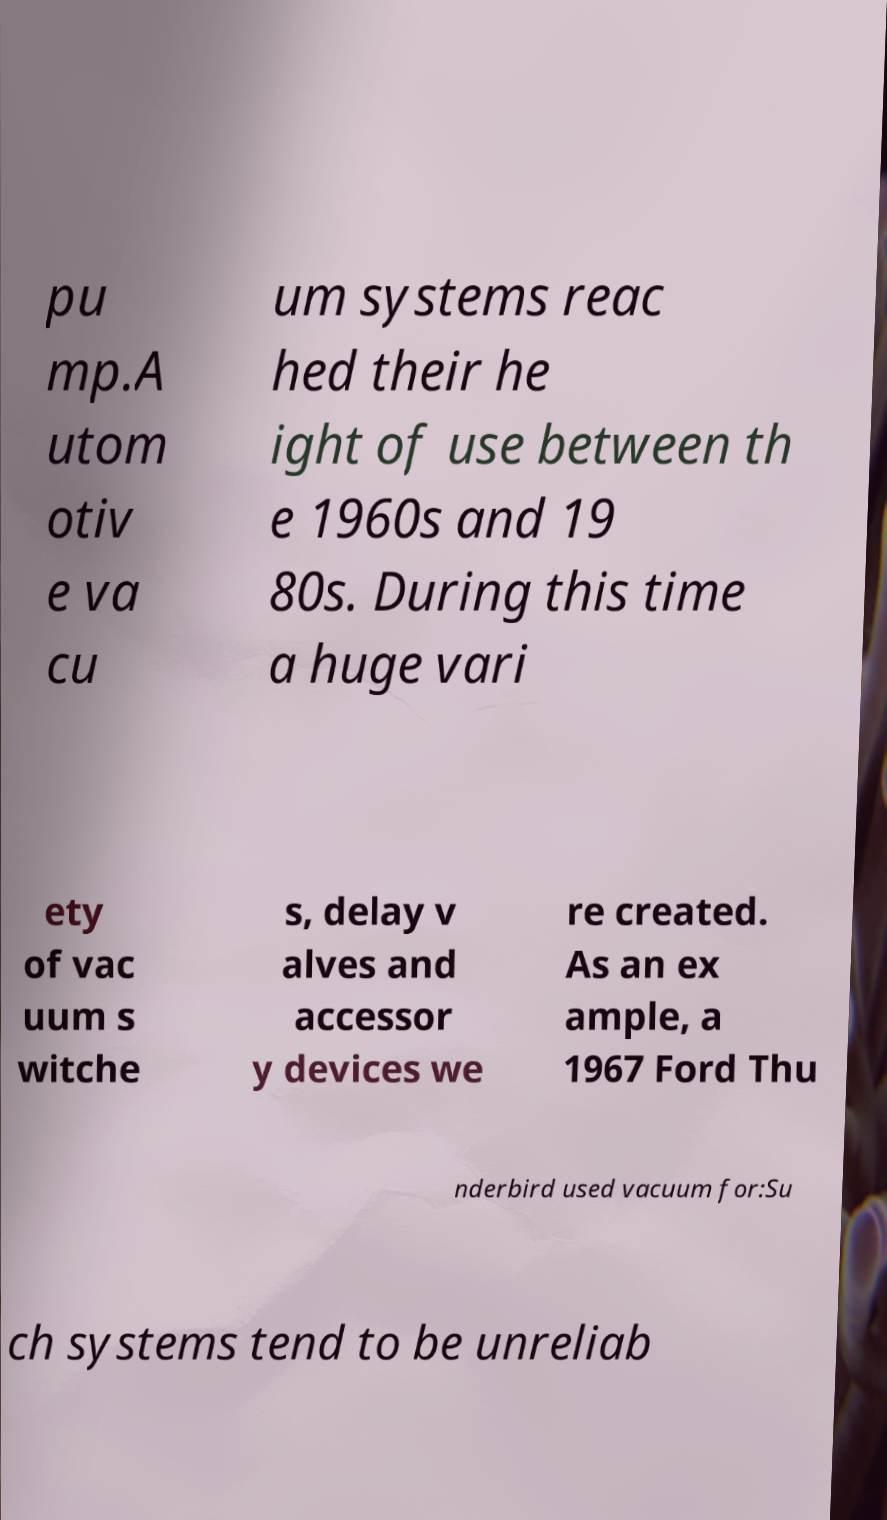Could you extract and type out the text from this image? pu mp.A utom otiv e va cu um systems reac hed their he ight of use between th e 1960s and 19 80s. During this time a huge vari ety of vac uum s witche s, delay v alves and accessor y devices we re created. As an ex ample, a 1967 Ford Thu nderbird used vacuum for:Su ch systems tend to be unreliab 